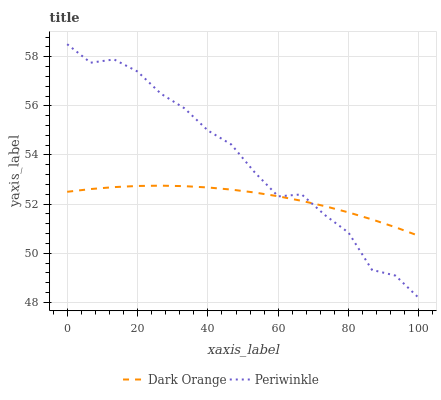Does Dark Orange have the minimum area under the curve?
Answer yes or no. Yes. Does Periwinkle have the maximum area under the curve?
Answer yes or no. Yes. Does Periwinkle have the minimum area under the curve?
Answer yes or no. No. Is Dark Orange the smoothest?
Answer yes or no. Yes. Is Periwinkle the roughest?
Answer yes or no. Yes. Is Periwinkle the smoothest?
Answer yes or no. No. Does Periwinkle have the lowest value?
Answer yes or no. Yes. Does Periwinkle have the highest value?
Answer yes or no. Yes. Does Periwinkle intersect Dark Orange?
Answer yes or no. Yes. Is Periwinkle less than Dark Orange?
Answer yes or no. No. Is Periwinkle greater than Dark Orange?
Answer yes or no. No. 